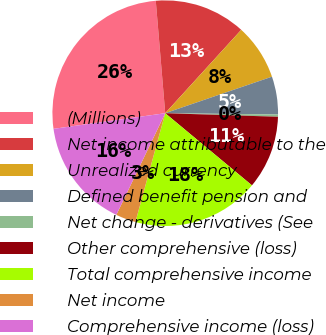Convert chart to OTSL. <chart><loc_0><loc_0><loc_500><loc_500><pie_chart><fcel>(Millions)<fcel>Net income attributable to the<fcel>Unrealized currency<fcel>Defined benefit pension and<fcel>Net change - derivatives (See<fcel>Other comprehensive (loss)<fcel>Total comprehensive income<fcel>Net income<fcel>Comprehensive income (loss)<nl><fcel>25.88%<fcel>13.1%<fcel>7.99%<fcel>5.43%<fcel>0.32%<fcel>10.54%<fcel>18.21%<fcel>2.88%<fcel>15.65%<nl></chart> 